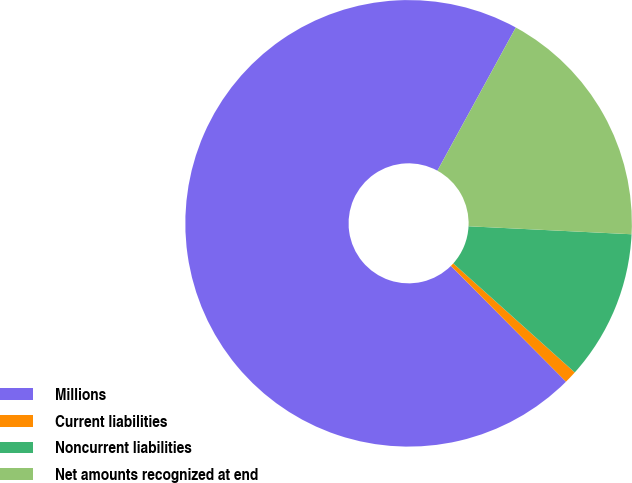Convert chart to OTSL. <chart><loc_0><loc_0><loc_500><loc_500><pie_chart><fcel>Millions<fcel>Current liabilities<fcel>Noncurrent liabilities<fcel>Net amounts recognized at end<nl><fcel>70.43%<fcel>0.91%<fcel>10.86%<fcel>17.81%<nl></chart> 